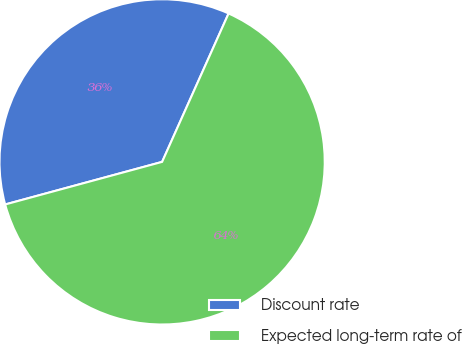Convert chart. <chart><loc_0><loc_0><loc_500><loc_500><pie_chart><fcel>Discount rate<fcel>Expected long-term rate of<nl><fcel>35.92%<fcel>64.08%<nl></chart> 